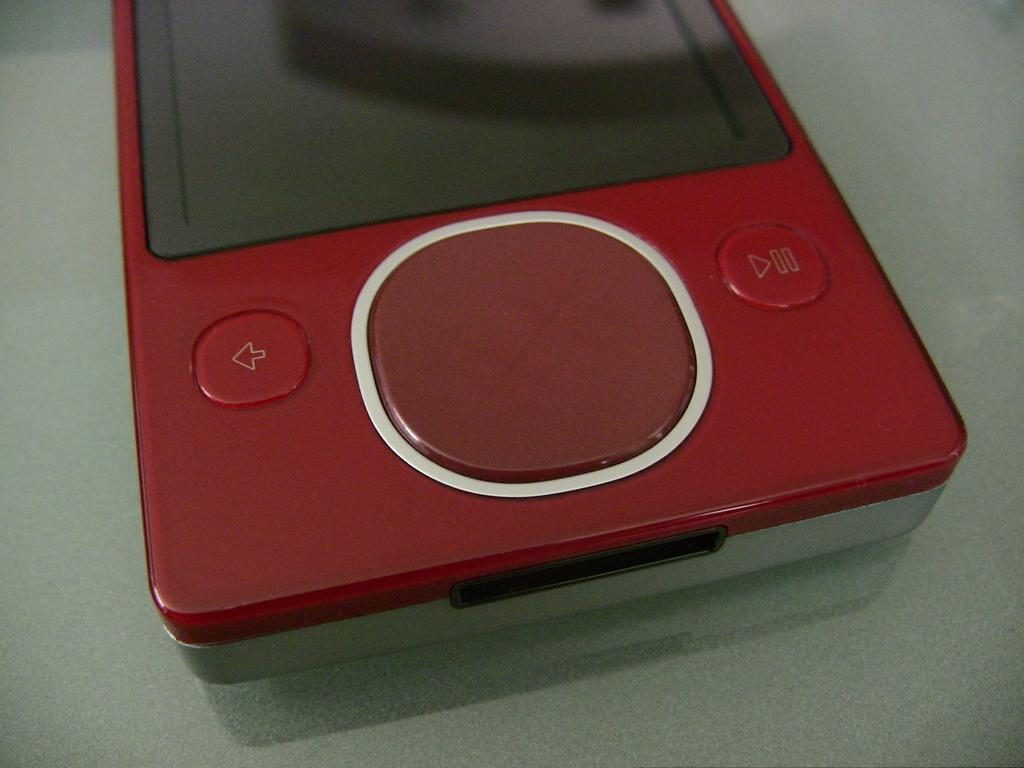What electronic device is visible in the image? There is an iPad in the image. What color is the iPad? The iPad is red in color. On what surface is the iPad placed? The iPad is placed on a white surface. How is the coal being used in the image? There is no coal present in the image. 